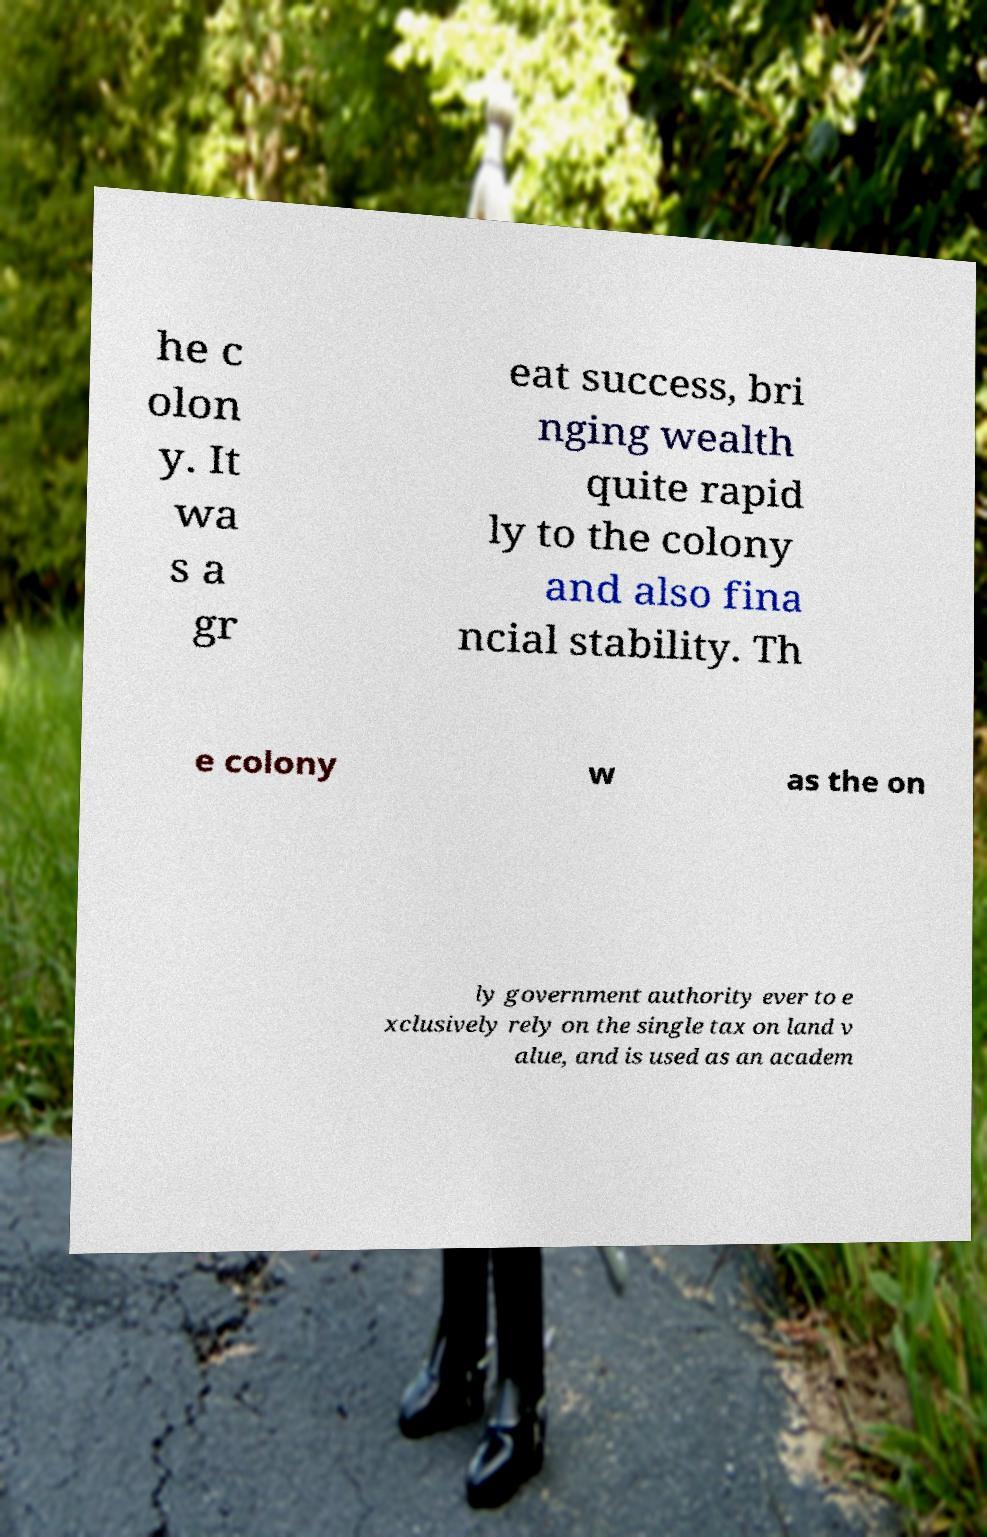I need the written content from this picture converted into text. Can you do that? he c olon y. It wa s a gr eat success, bri nging wealth quite rapid ly to the colony and also fina ncial stability. Th e colony w as the on ly government authority ever to e xclusively rely on the single tax on land v alue, and is used as an academ 